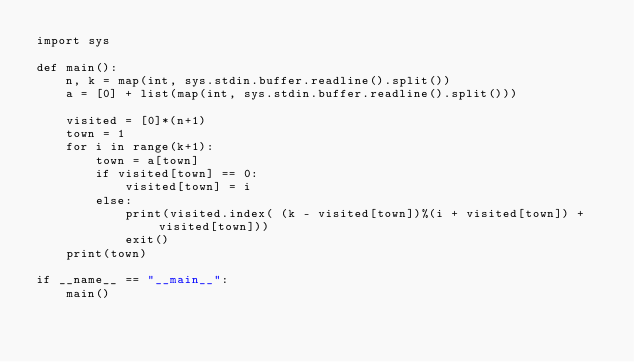<code> <loc_0><loc_0><loc_500><loc_500><_Python_>import sys

def main():
    n, k = map(int, sys.stdin.buffer.readline().split())
    a = [0] + list(map(int, sys.stdin.buffer.readline().split()))

    visited = [0]*(n+1)
    town = 1
    for i in range(k+1):
        town = a[town]
        if visited[town] == 0:
            visited[town] = i
        else:
            print(visited.index( (k - visited[town])%(i + visited[town]) + visited[town]))
            exit()
    print(town)

if __name__ == "__main__":
    main()</code> 